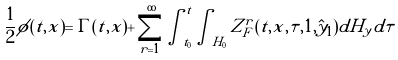Convert formula to latex. <formula><loc_0><loc_0><loc_500><loc_500>\frac { 1 } { 2 } \phi ( t , x ) = \Gamma ( t , x ) + \sum _ { r = 1 } ^ { \infty } \int _ { t _ { 0 } } ^ { t } \int _ { H _ { 0 } } Z ^ { r } _ { F } ( t , x , \tau , 1 , \hat { y } _ { 1 } ) d H _ { y } d \tau</formula> 